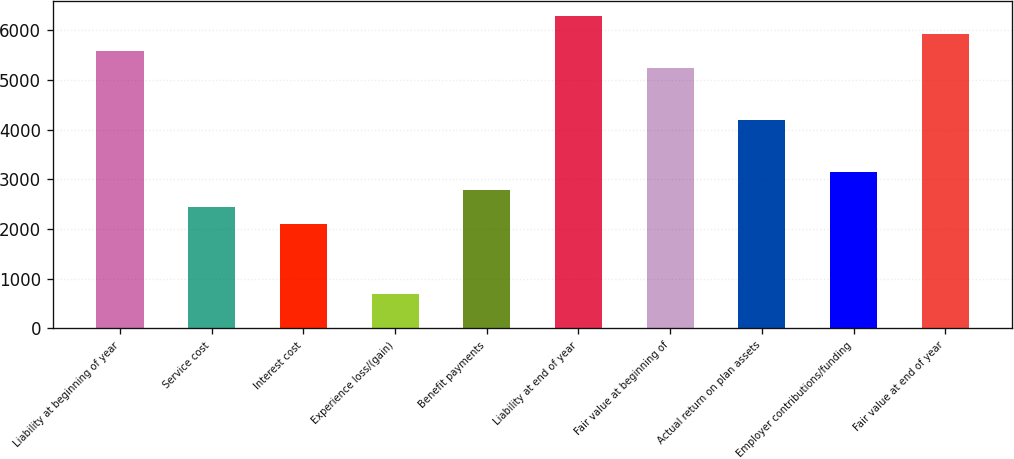Convert chart. <chart><loc_0><loc_0><loc_500><loc_500><bar_chart><fcel>Liability at beginning of year<fcel>Service cost<fcel>Interest cost<fcel>Experience loss/(gain)<fcel>Benefit payments<fcel>Liability at end of year<fcel>Fair value at beginning of<fcel>Actual return on plan assets<fcel>Employer contributions/funding<fcel>Fair value at end of year<nl><fcel>5583.4<fcel>2443.3<fcel>2094.4<fcel>698.8<fcel>2792.2<fcel>6281.2<fcel>5234.5<fcel>4187.8<fcel>3141.1<fcel>5932.3<nl></chart> 